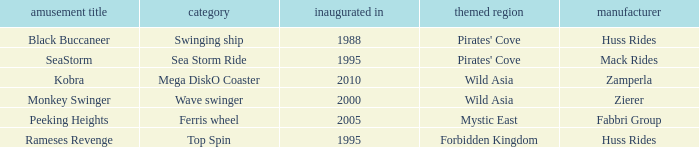What kind of ride is rameses revenge? Top Spin. Can you give me this table as a dict? {'header': ['amusement title', 'category', 'inaugurated in', 'themed region', 'manufacturer'], 'rows': [['Black Buccaneer', 'Swinging ship', '1988', "Pirates' Cove", 'Huss Rides'], ['SeaStorm', 'Sea Storm Ride', '1995', "Pirates' Cove", 'Mack Rides'], ['Kobra', 'Mega DiskO Coaster', '2010', 'Wild Asia', 'Zamperla'], ['Monkey Swinger', 'Wave swinger', '2000', 'Wild Asia', 'Zierer'], ['Peeking Heights', 'Ferris wheel', '2005', 'Mystic East', 'Fabbri Group'], ['Rameses Revenge', 'Top Spin', '1995', 'Forbidden Kingdom', 'Huss Rides']]} 